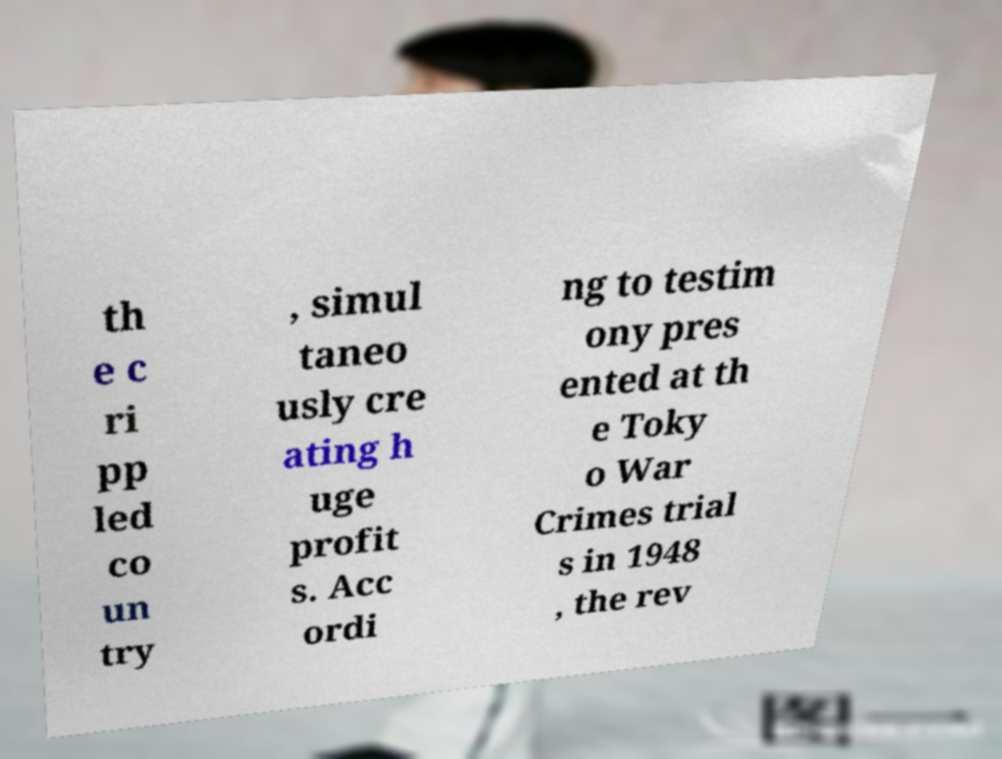Please read and relay the text visible in this image. What does it say? th e c ri pp led co un try , simul taneo usly cre ating h uge profit s. Acc ordi ng to testim ony pres ented at th e Toky o War Crimes trial s in 1948 , the rev 